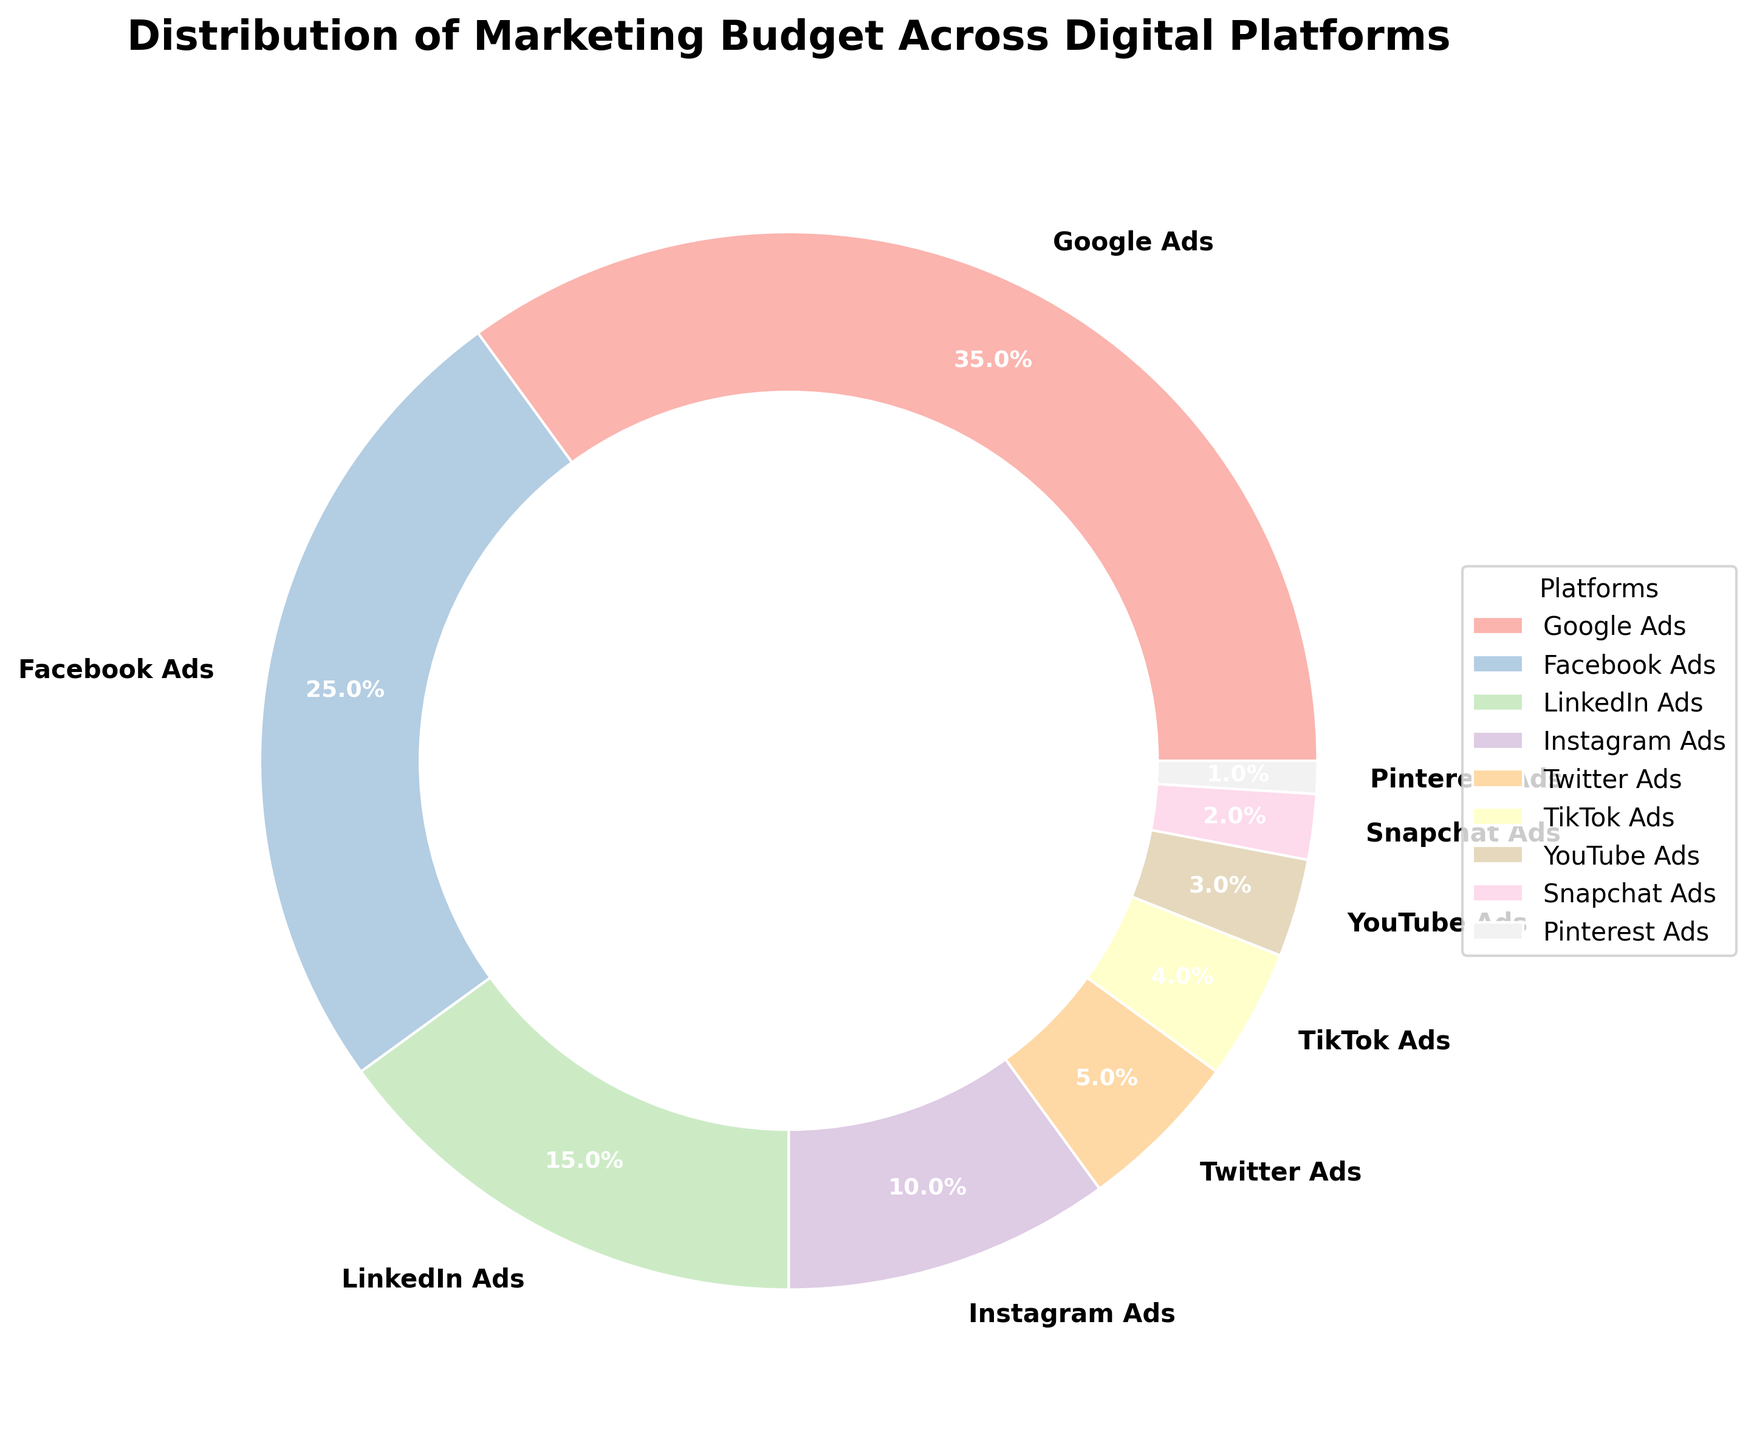Which platform has the largest portion of the marketing budget? By looking at the pie chart, the segment with the largest size represents the platform with the largest portion. Google Ads has the largest portion shown on the chart.
Answer: Google Ads Which platforms together make up more than half of the marketing budget? First, identify each individual percentage. Google Ads has 35%, and Facebook Ads has 25%. Together, 35% + 25% = 60%, which is more than half.
Answer: Google Ads and Facebook Ads Compare the budget proportions of LinkedIn Ads and Instagram Ads. Which one is larger? By how much? LinkedIn Ads have 15% and Instagram Ads have 10%. To find out which is larger and by how much, subtract the smaller percentage from the larger: 15% - 10% = 5%.
Answer: LinkedIn Ads by 5% What is the total percentage of the marketing budget allocated to the bottom three platforms? Identify the bottom three platforms and sum their percentages. Pinterest Ads have 1%, Snapchat Ads have 2%, and YouTube Ads have 3%. Adding them up: 1% + 2% + 3% = 6%.
Answer: 6% Which platform has the smallest portion of the marketing budget? The smallest section of the pie chart corresponds to Pinterest Ads, which has the smallest percentage.
Answer: Pinterest Ads Compare the combined budget of TikTok Ads and Twitter Ads with the budget for LinkedIn Ads. Which is greater? TikTok Ads have 4% and Twitter Ads have 5%. Combined, 4% + 5% = 9%. LinkedIn Ads have 15%. LinkedIn Ads have a greater portion.
Answer: LinkedIn Ads How does the budget for YouTube Ads compare to that of TikTok Ads? YouTube Ads have 3% and TikTok Ads have 4%. TikTok Ads have a 1% larger portion than YouTube Ads: 4% - 3% = 1%.
Answer: TikTok Ads are 1% larger What is the combined percentage of budget allocation for platforms other than Google Ads and Facebook Ads? Add up all the other percentages except for Google Ads and Facebook Ads: 15% (LinkedIn) + 10% (Instagram) + 5% (Twitter) + 4% (TikTok) + 3% (YouTube) + 2% (Snapchat) + 1% (Pinterest) = 40%.
Answer: 40% How does the budget allocation for Facebook Ads compare to Instagram Ads, and by how many times is it larger or smaller? Facebook Ads have 25% and Instagram Ads have 10%. To find out how many times larger, divide the larger percentage by the smaller: 25% / 10% = 2.5.
Answer: Facebook Ads is 2.5 times larger Which platforms combined have exactly the same budget allocation as Google Ads? Since Google Ads has 35%, find platforms that sum up to that percentage. LinkedIn Ads, Instagram Ads, and Twitter Ads together: 15% + 10% + 5% = 30%. There's no exact match, but platforms such as LinkedIn Ads, Instagram Ads, Twitter Ads, and Pinterest Ads combined yield closest (15% + 10% + 5% + 1% = 31%). The exact match cannot be made; this demonstrates understanding in reasoning about missing exact combinations.
Answer: No exact match 